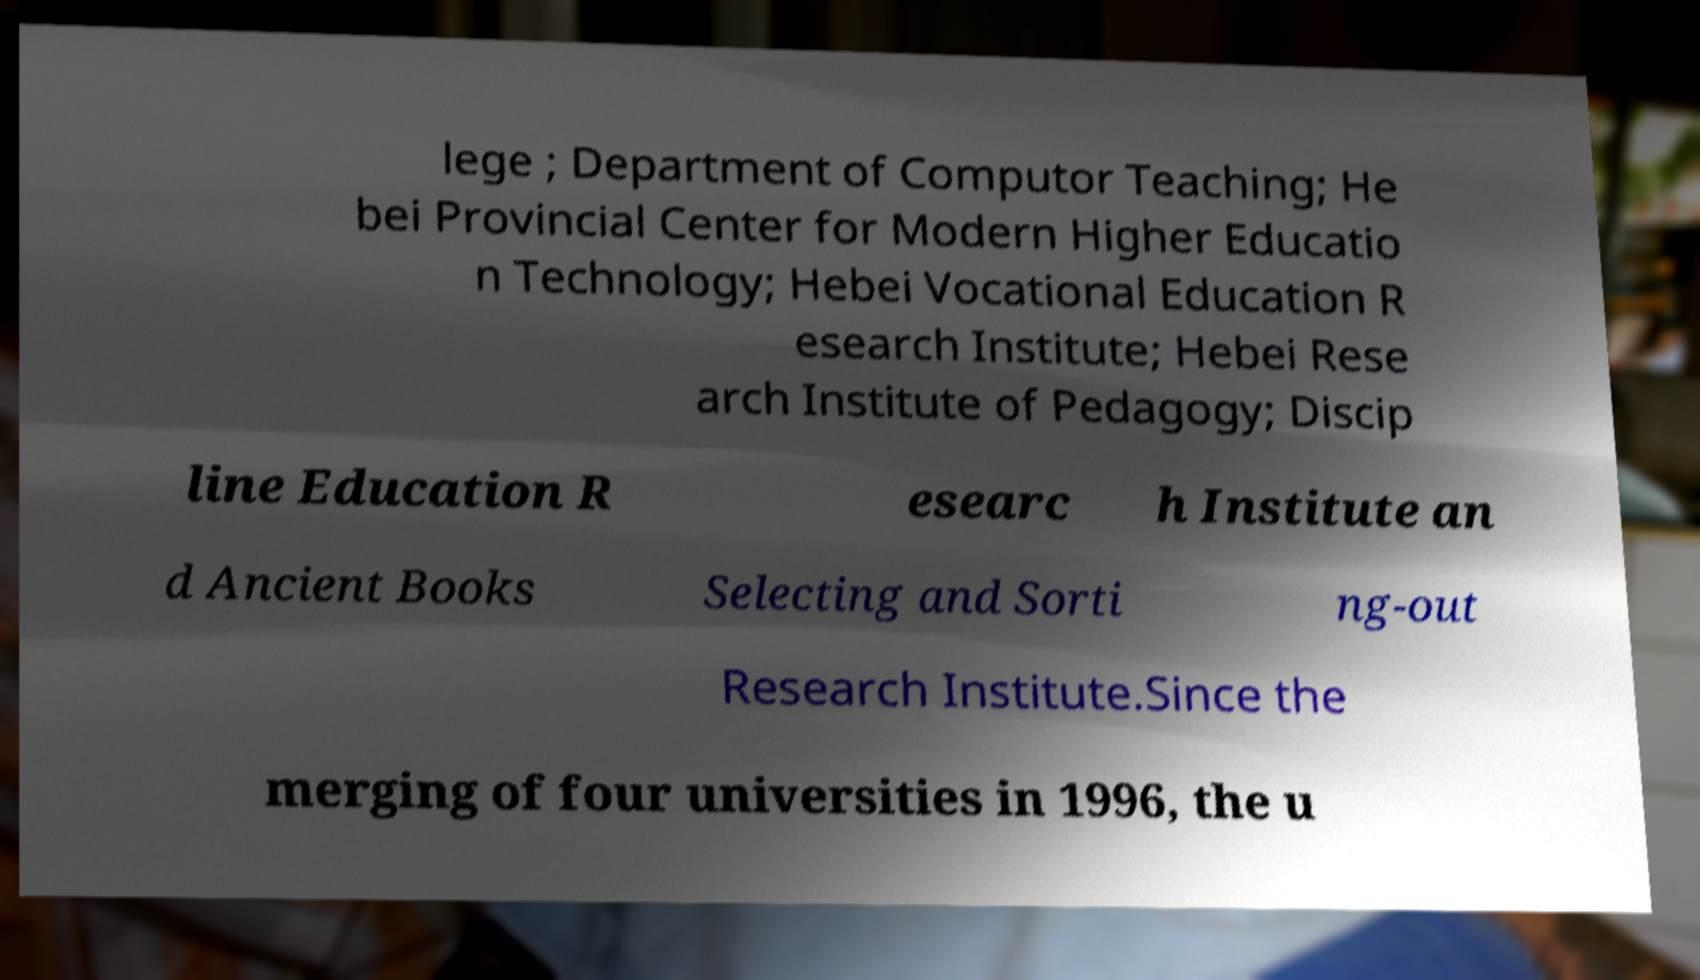Please read and relay the text visible in this image. What does it say? lege ; Department of Computor Teaching; He bei Provincial Center for Modern Higher Educatio n Technology; Hebei Vocational Education R esearch Institute; Hebei Rese arch Institute of Pedagogy; Discip line Education R esearc h Institute an d Ancient Books Selecting and Sorti ng-out Research Institute.Since the merging of four universities in 1996, the u 